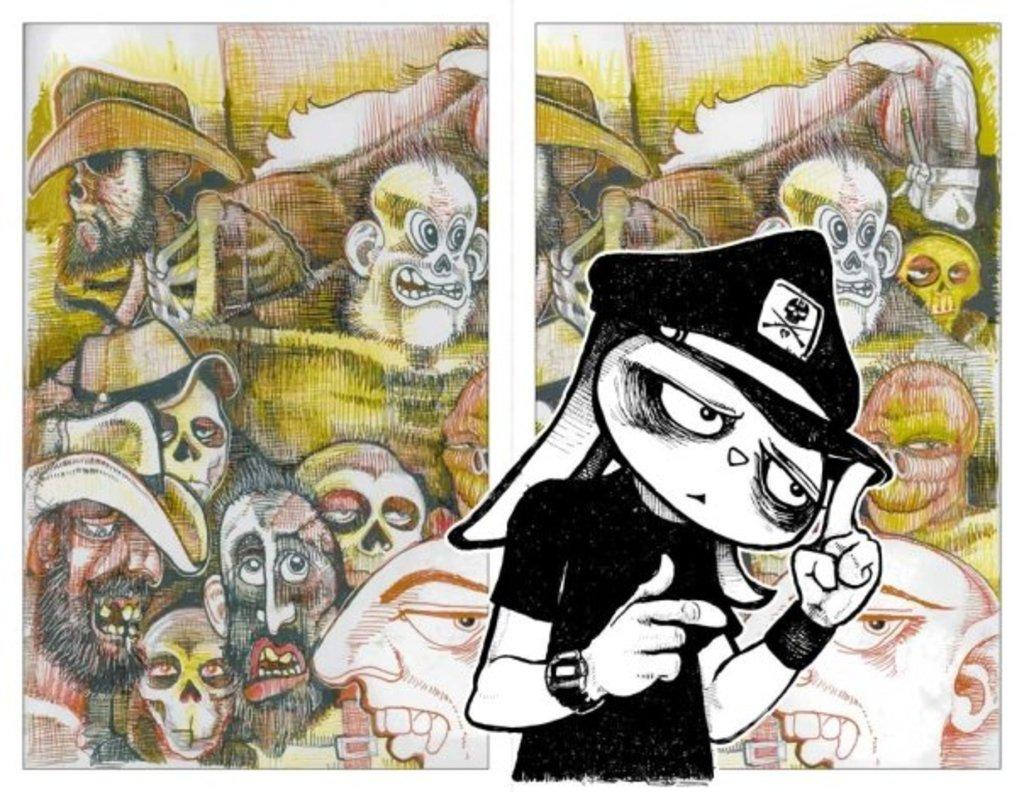What is the main subject of the image? The main subject of the image is a drawing. Can you describe the drawing in more detail? The drawing contains different characters. What type of pear is being used as a prop by one of the characters in the drawing? There is no pear present in the image, as the drawing contains different characters but does not specify any objects or props they might be using. 